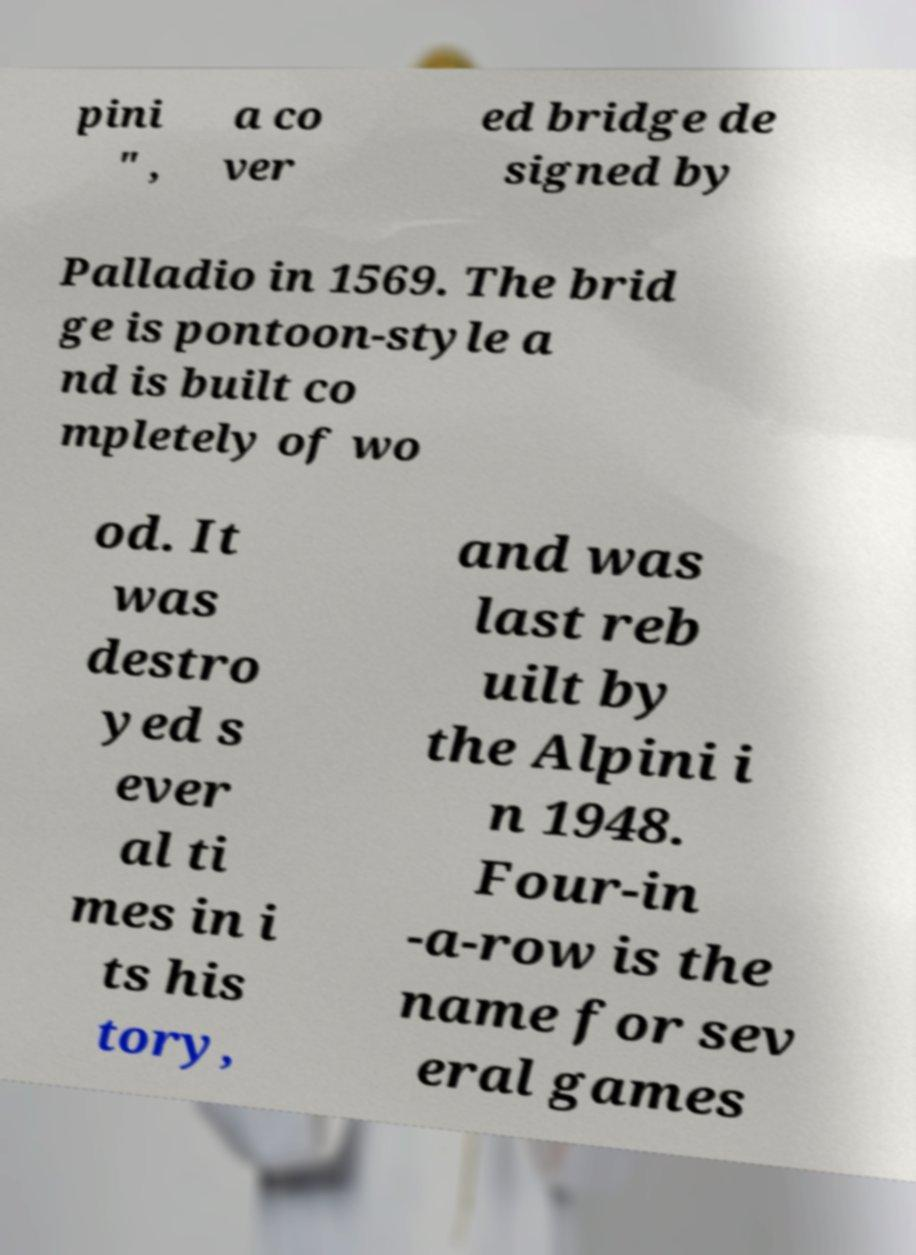I need the written content from this picture converted into text. Can you do that? pini " , a co ver ed bridge de signed by Palladio in 1569. The brid ge is pontoon-style a nd is built co mpletely of wo od. It was destro yed s ever al ti mes in i ts his tory, and was last reb uilt by the Alpini i n 1948. Four-in -a-row is the name for sev eral games 